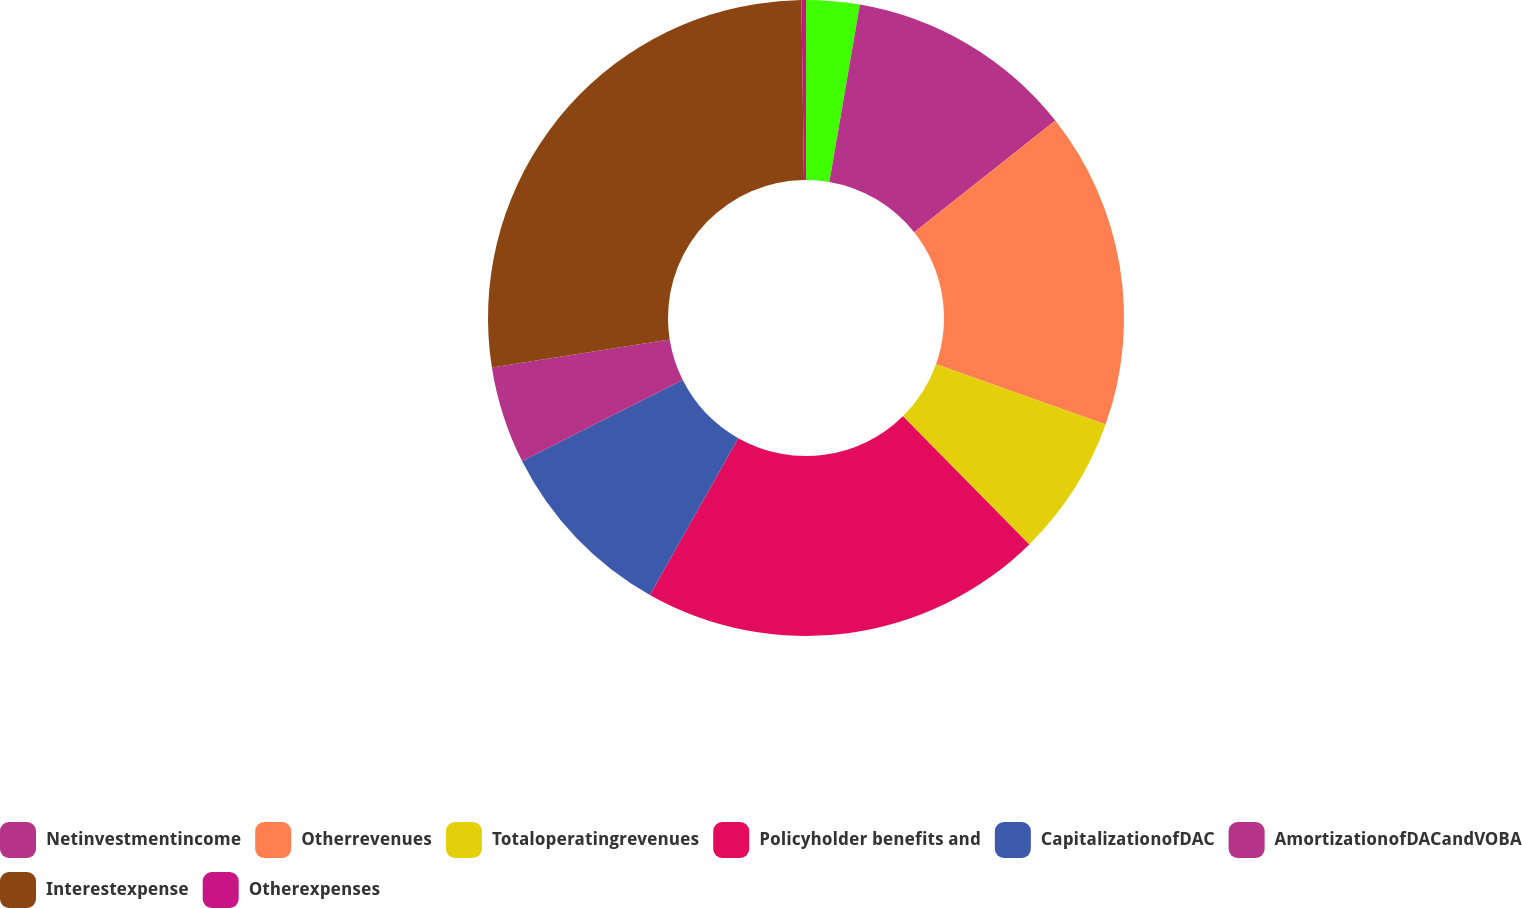<chart> <loc_0><loc_0><loc_500><loc_500><pie_chart><ecel><fcel>Netinvestmentincome<fcel>Otherrevenues<fcel>Totaloperatingrevenues<fcel>Policyholder benefits and<fcel>CapitalizationofDAC<fcel>AmortizationofDACandVOBA<fcel>Interestexpense<fcel>Otherexpenses<nl><fcel>2.71%<fcel>11.63%<fcel>16.1%<fcel>7.17%<fcel>20.56%<fcel>9.4%<fcel>4.94%<fcel>27.26%<fcel>0.23%<nl></chart> 